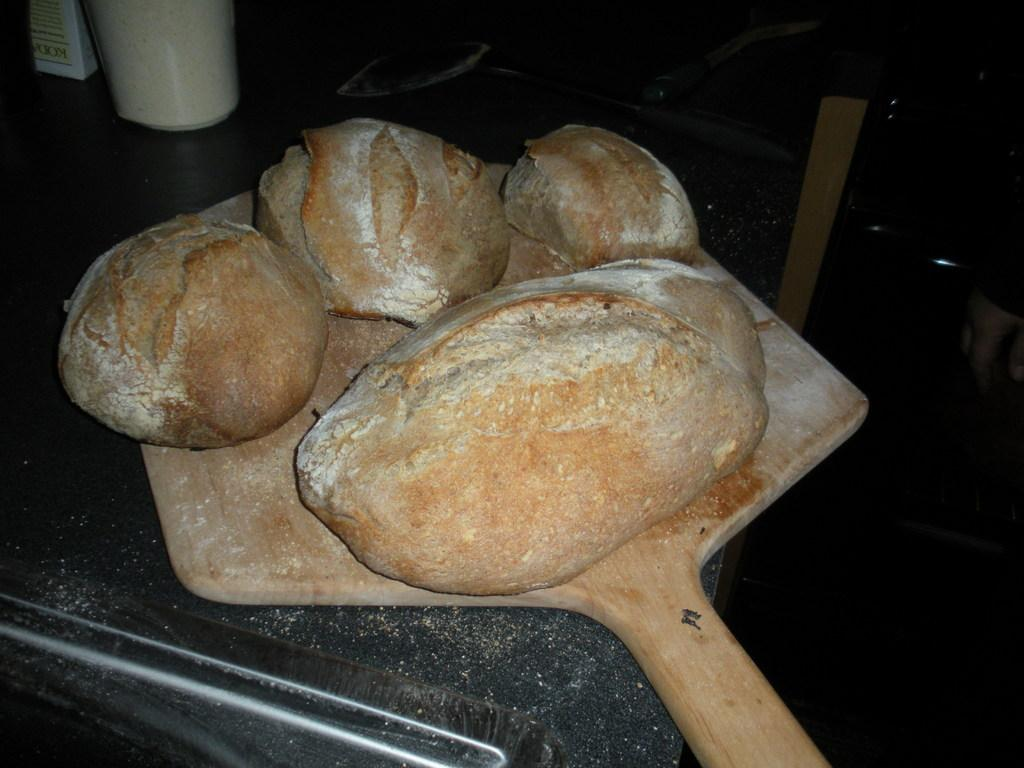What is the main subject of the image? The main subject of the image is dough. Where is the dough placed? The dough is placed on a wooden plate. What is the wooden plate resting on? The wooden plate is on a table. What is the color of the table? The table is black in color. How would you describe the lighting in the image? The background of the image is dark. Are there any icicles hanging from the table in the image? No, there are no icicles present in the image. What type of plantation can be seen in the background of the image? There is no plantation visible in the image; the background is dark. 